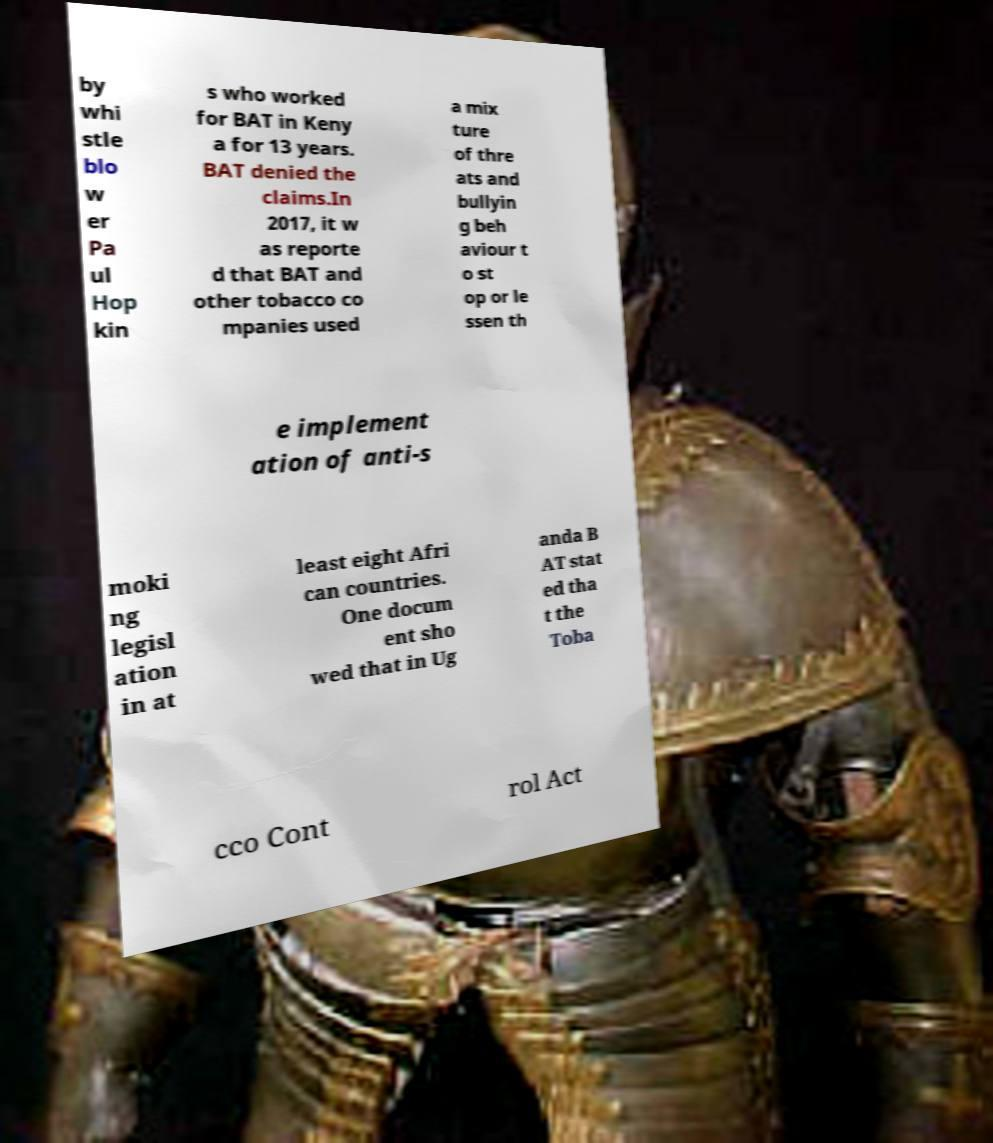I need the written content from this picture converted into text. Can you do that? by whi stle blo w er Pa ul Hop kin s who worked for BAT in Keny a for 13 years. BAT denied the claims.In 2017, it w as reporte d that BAT and other tobacco co mpanies used a mix ture of thre ats and bullyin g beh aviour t o st op or le ssen th e implement ation of anti-s moki ng legisl ation in at least eight Afri can countries. One docum ent sho wed that in Ug anda B AT stat ed tha t the Toba cco Cont rol Act 